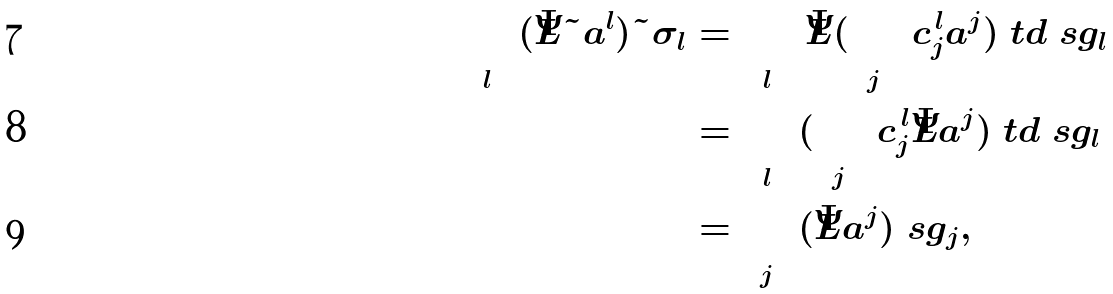Convert formula to latex. <formula><loc_0><loc_0><loc_500><loc_500>\sum _ { l } ( \bar { L } \tilde { a } ^ { l } ) \tilde { \sigma } _ { l } & = \sum _ { l } { \bar { L } } ( \sum _ { j } c _ { j } ^ { \, l } a ^ { j } ) \ t d \ s g _ { l } \\ & = \sum _ { l } ( \sum _ { j } c _ { j } ^ { \, l } \bar { L } a ^ { j } ) \ t d \ s g _ { l } \\ & = \sum _ { j } ( \bar { L } a ^ { j } ) \ s g _ { j } ,</formula> 